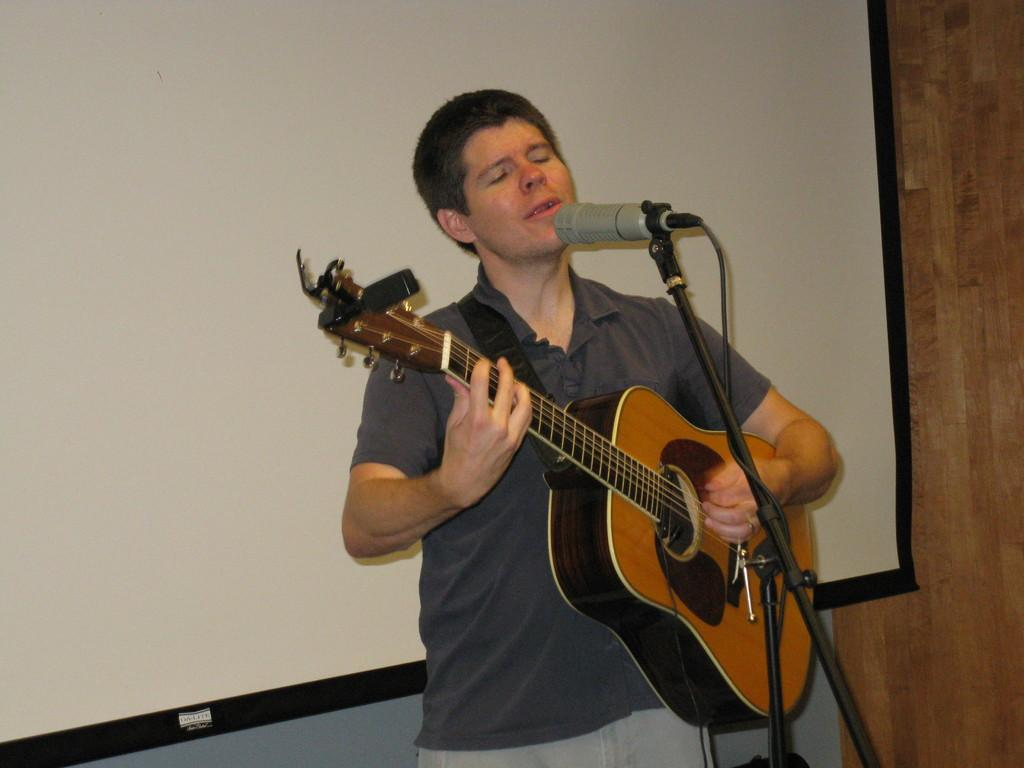What is the man in the image doing? The man is playing a guitar and singing into a microphone. What instrument is the man playing in the image? The man is playing a guitar. What can be seen in the background of the image? There is a screen and a wall in the background of the image. What type of seed is the man planting near the hydrant in the image? There is no seed or hydrant present in the image. How does the man approach the edge of the stage in the image? There is no stage or edge mentioned in the image; the man is playing a guitar and singing into a microphone. 